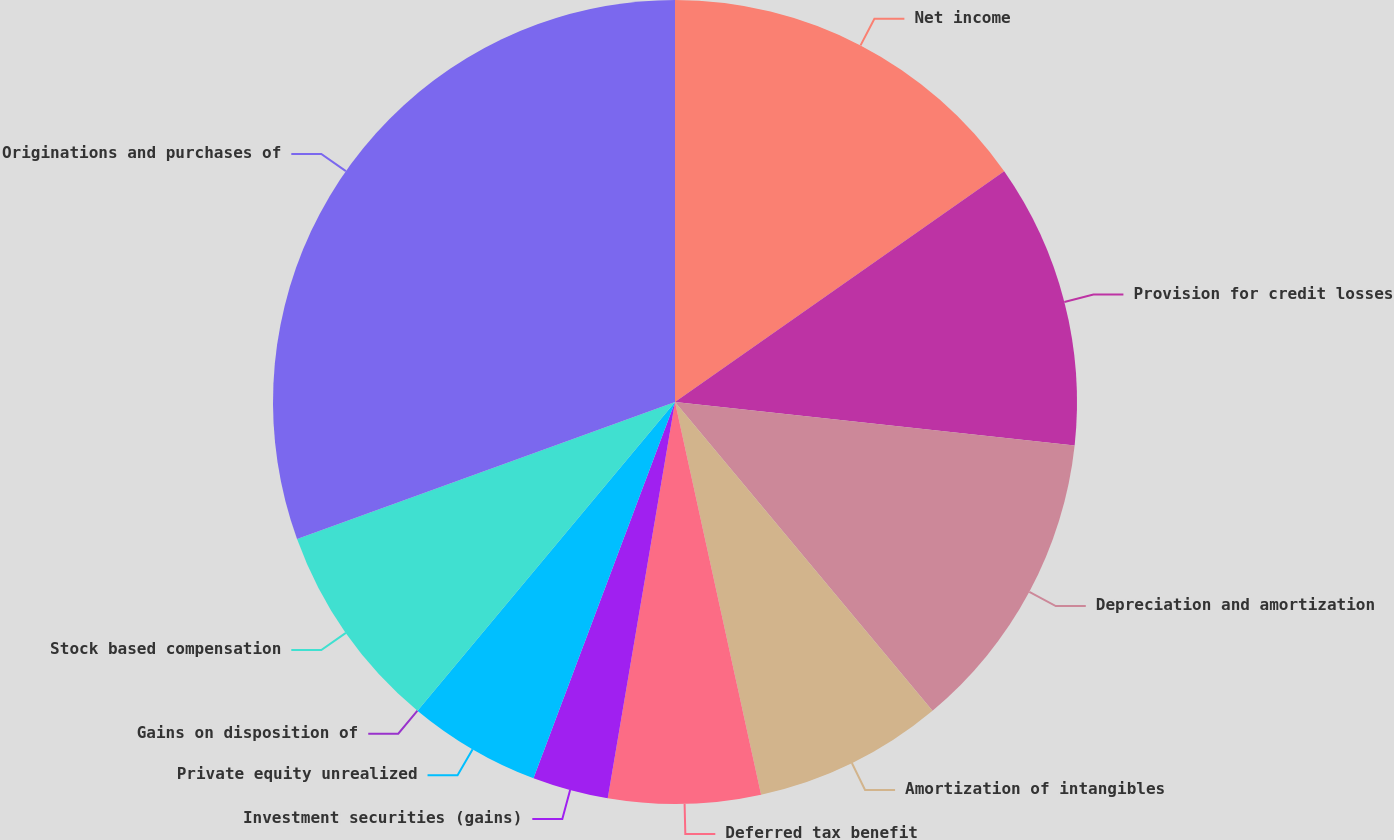Convert chart to OTSL. <chart><loc_0><loc_0><loc_500><loc_500><pie_chart><fcel>Net income<fcel>Provision for credit losses<fcel>Depreciation and amortization<fcel>Amortization of intangibles<fcel>Deferred tax benefit<fcel>Investment securities (gains)<fcel>Private equity unrealized<fcel>Gains on disposition of<fcel>Stock based compensation<fcel>Originations and purchases of<nl><fcel>15.27%<fcel>11.45%<fcel>12.21%<fcel>7.63%<fcel>6.11%<fcel>3.05%<fcel>5.34%<fcel>0.0%<fcel>8.4%<fcel>30.53%<nl></chart> 